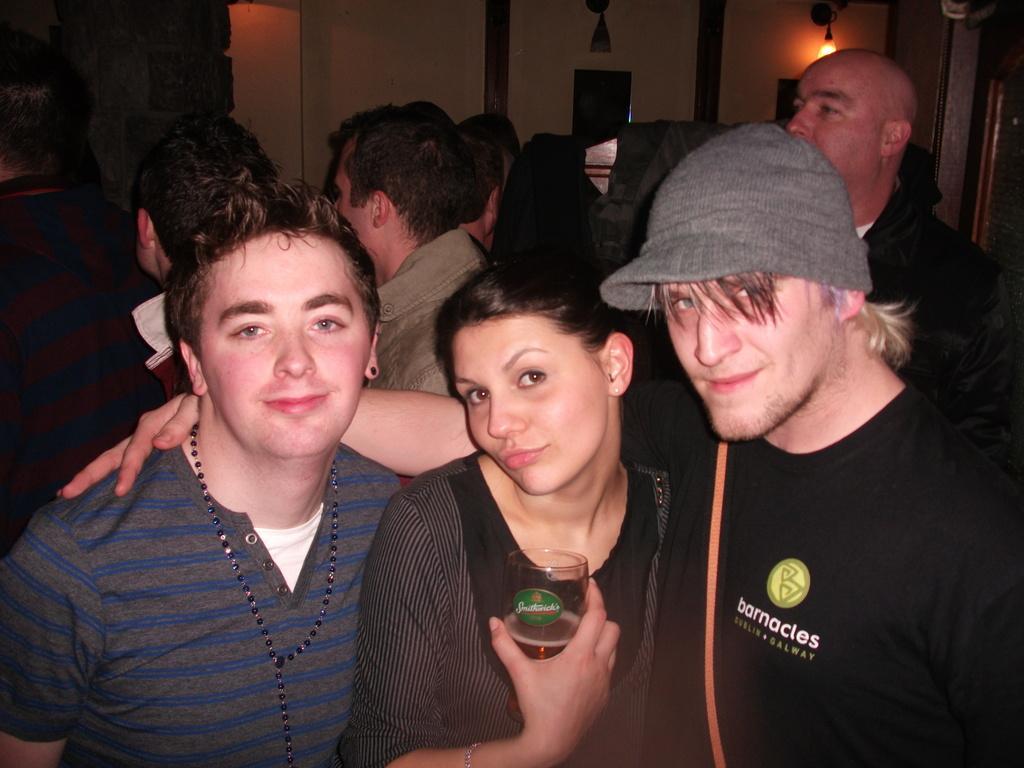Please provide a concise description of this image. We can see three persons are standing and the woman in the middle is holding a glass with liquid in it in her hand. In the background there are few persons,wall,clothes on an object and a light on the right side at the top. 